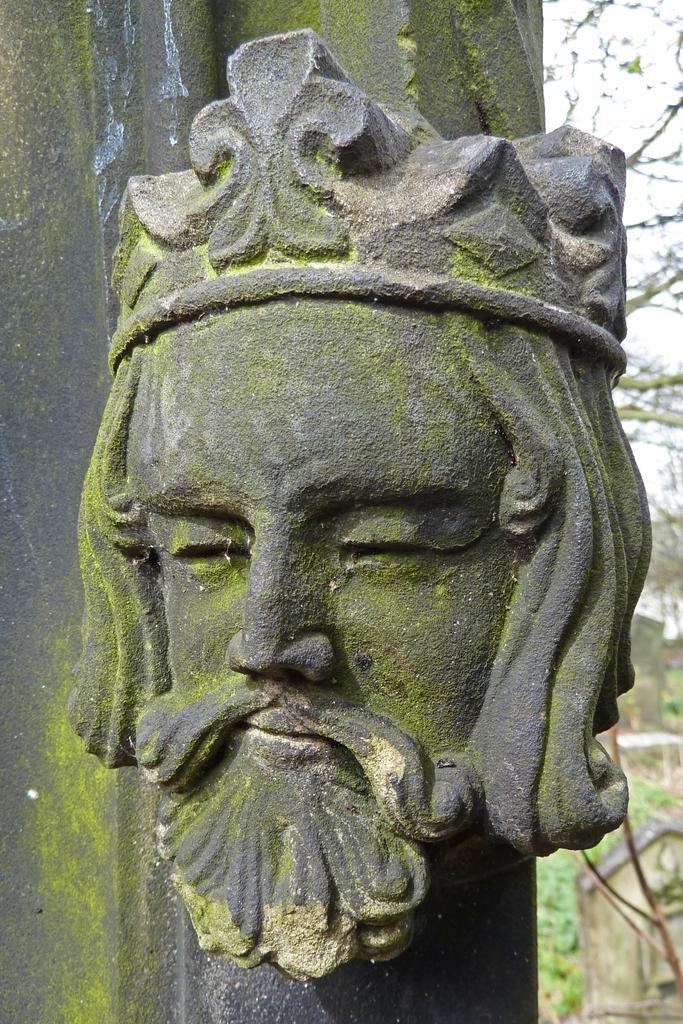Can you describe this image briefly? In this picture we can see a stone sculpture of a man's face with a beard and a crown on his head. In the background, we can see trees. 